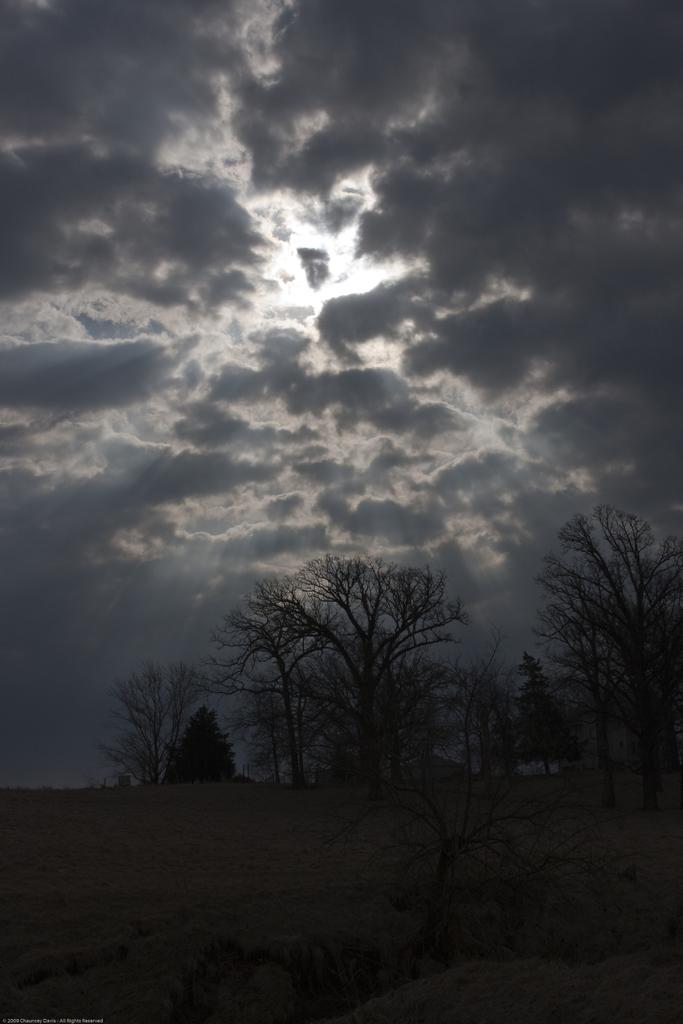In one or two sentences, can you explain what this image depicts? In this image there are trees, at the top of the image there are clouds in the sky. 